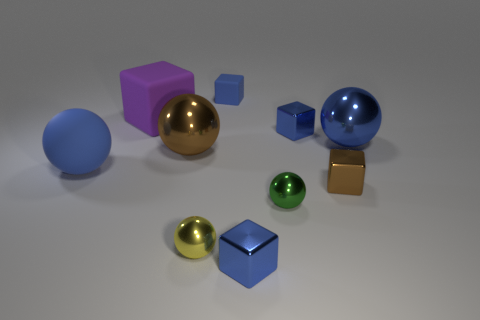Subtract all brown balls. How many blue cubes are left? 3 Subtract all yellow spheres. How many spheres are left? 4 Subtract all blue matte cubes. How many cubes are left? 4 Subtract all brown spheres. Subtract all cyan cubes. How many spheres are left? 4 Add 3 small yellow cylinders. How many small yellow cylinders exist? 3 Subtract 0 cyan cubes. How many objects are left? 10 Subtract all metallic things. Subtract all small metal spheres. How many objects are left? 1 Add 5 large purple things. How many large purple things are left? 6 